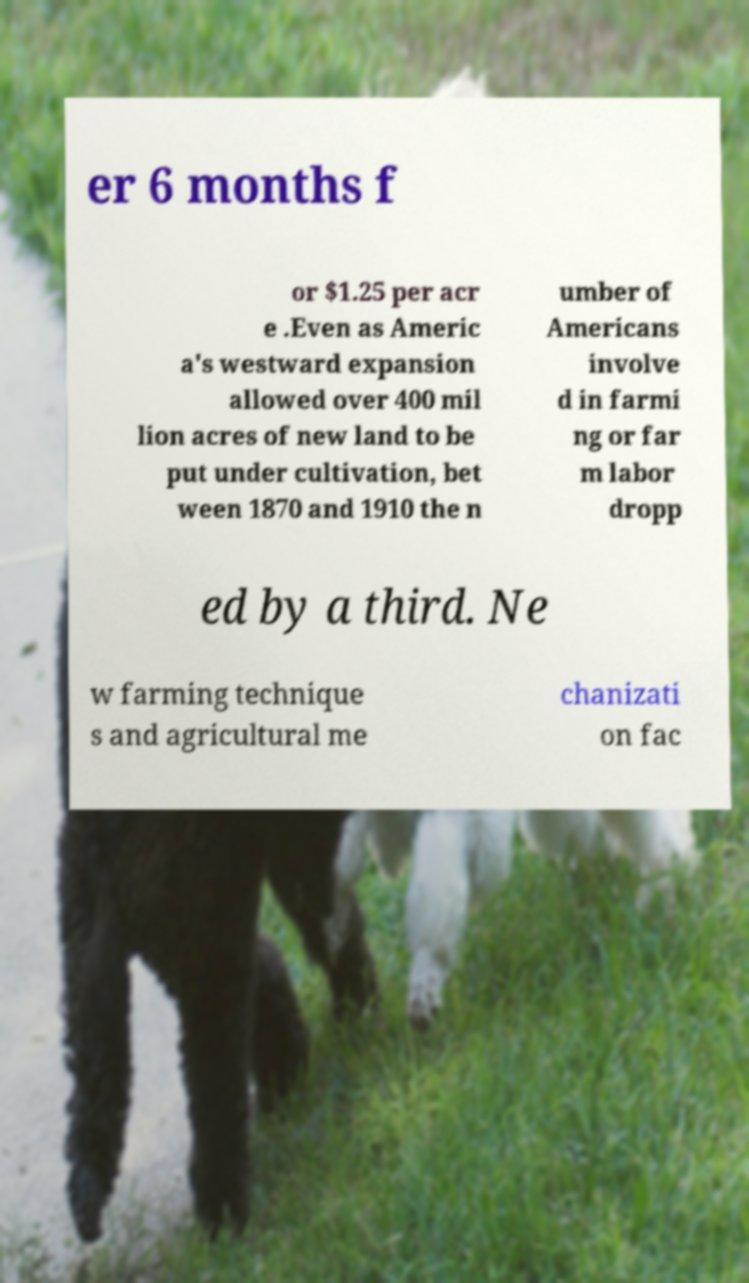What messages or text are displayed in this image? I need them in a readable, typed format. er 6 months f or $1.25 per acr e .Even as Americ a's westward expansion allowed over 400 mil lion acres of new land to be put under cultivation, bet ween 1870 and 1910 the n umber of Americans involve d in farmi ng or far m labor dropp ed by a third. Ne w farming technique s and agricultural me chanizati on fac 